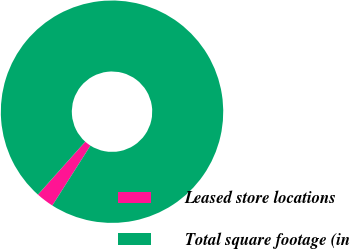Convert chart to OTSL. <chart><loc_0><loc_0><loc_500><loc_500><pie_chart><fcel>Leased store locations<fcel>Total square footage (in<nl><fcel>2.59%<fcel>97.41%<nl></chart> 